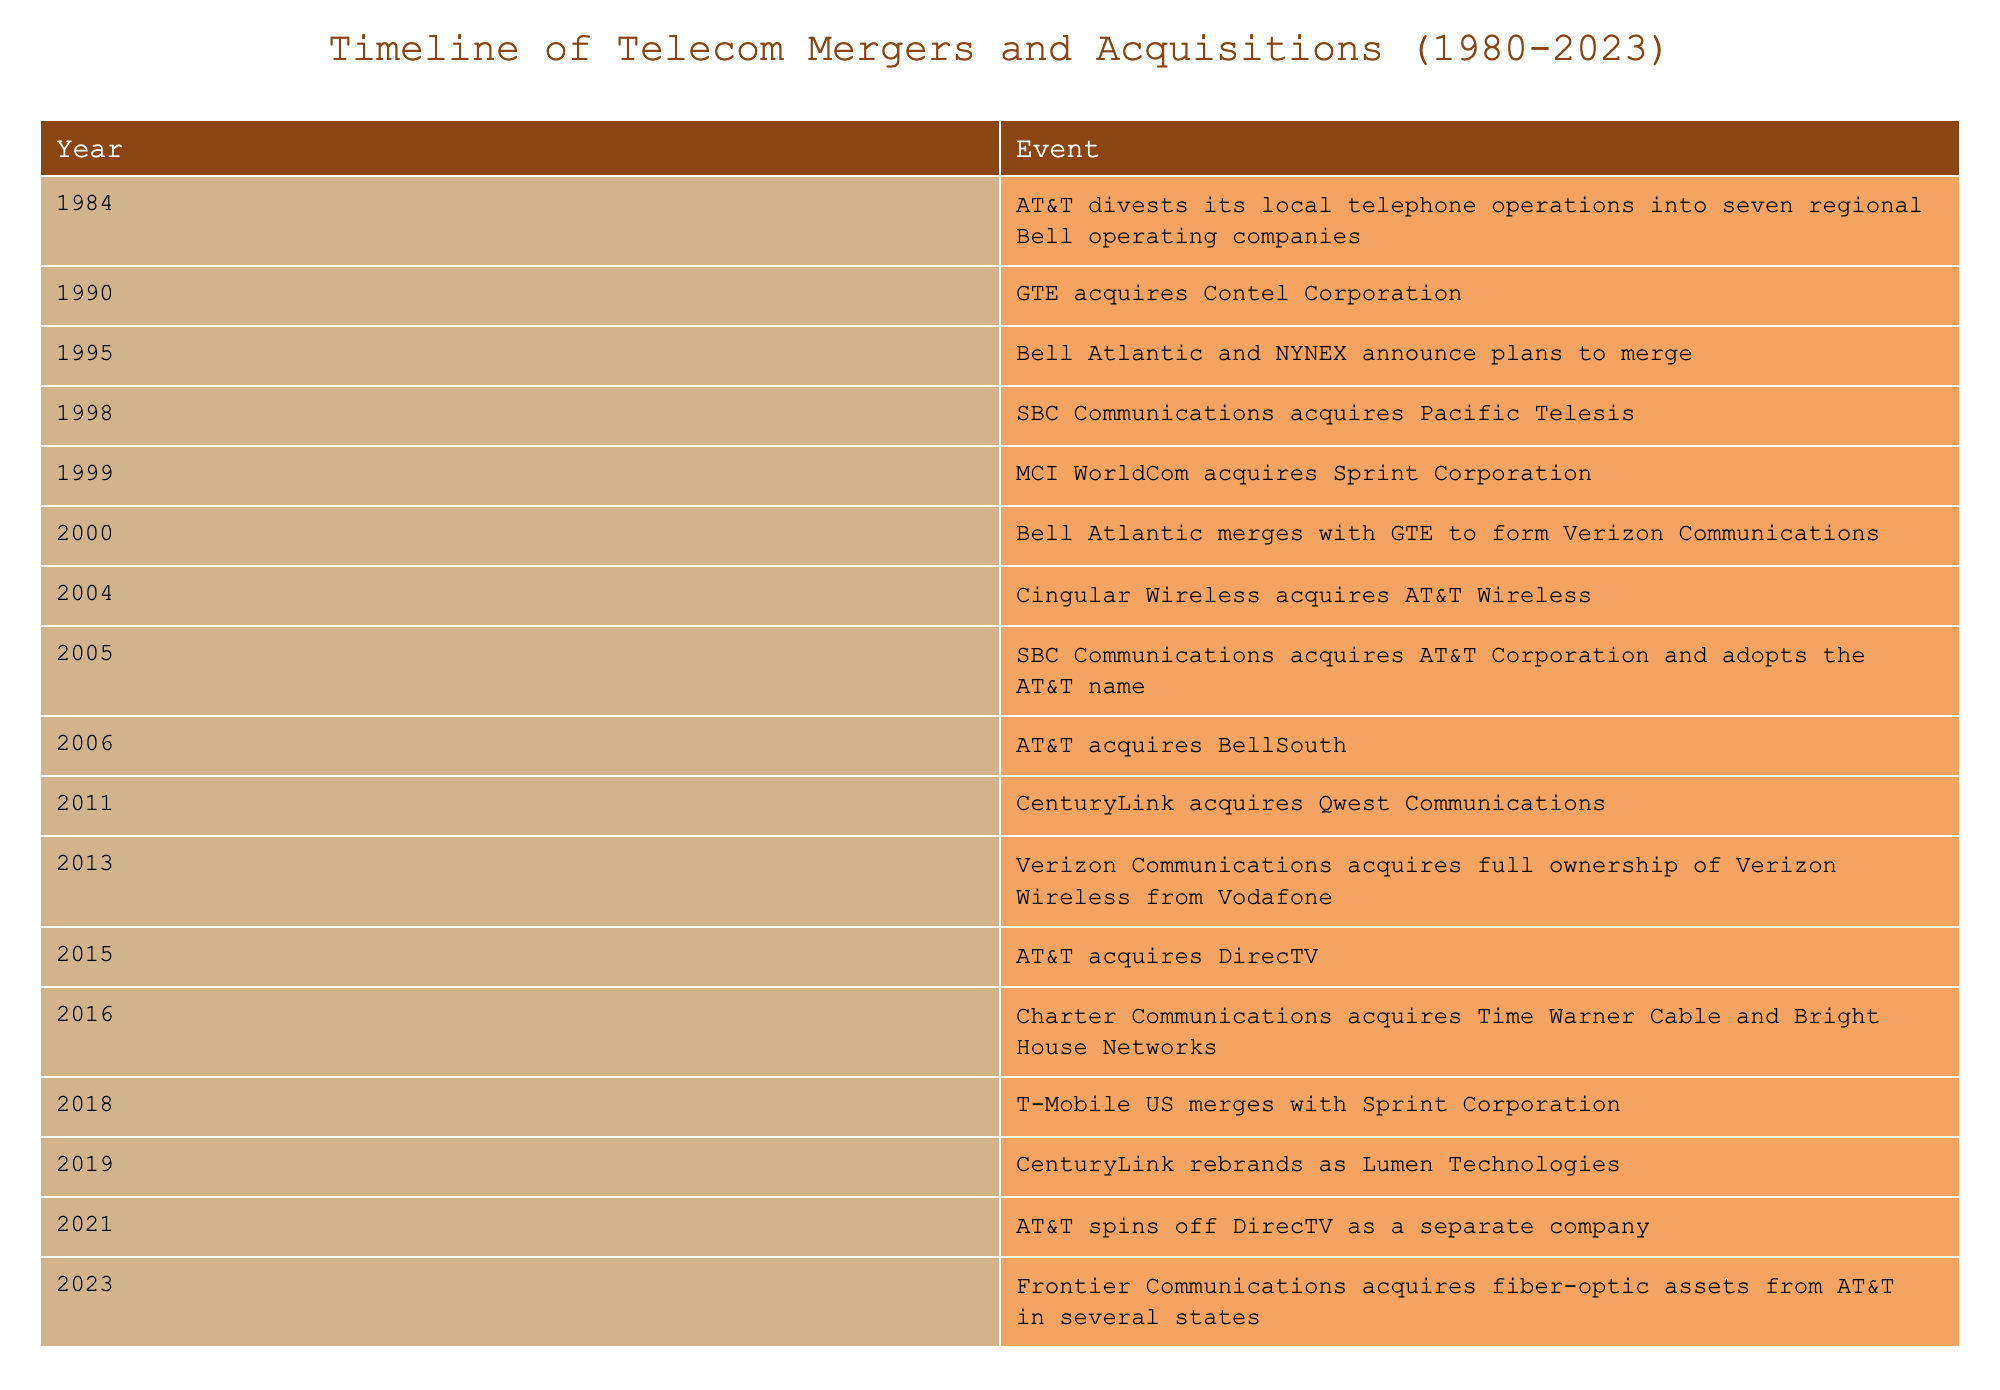What year did AT&T divest its local telephone operations? According to the table, AT&T divested its local telephone operations in 1984.
Answer: 1984 Which company acquired Contel Corporation in 1990? GTE is listed in the table as the company that acquired Contel Corporation in 1990.
Answer: GTE How many mergers or acquisitions occurred in the 2000s? The years in the 2000s listed in the table are 2000 (Bell Atlantic merges with GTE), 2004 (Cingular Wireless acquires AT&T Wireless), 2005 (SBC Communications acquires AT&T Corporation), and 2006 (AT&T acquires BellSouth), summing to four occurrences.
Answer: 4 Did CenturyLink acquire Qwest Communications before or after 2011? The table states that CenturyLink acquired Qwest Communications in 2011, which means the acquisition occurred in that year.
Answer: Before What is the chronological order of the significant mergers and acquisitions from 1995 to 2006? From the table, the events from 1995 to 2006 are as follows: 1995 (Bell Atlantic and NYNEX), 1998 (SBC Communications acquires Pacific Telesis), 1999 (MCI WorldCom acquires Sprint Corporation), 2000 (Bell Atlantic merges with GTE), 2004 (Cingular Wireless acquires AT&T Wireless), and 2005 (SBC Communications acquires AT&T Corporation), making the order: Bell Atlantic and NYNEX, SBC acquires Pacific Telesis, MCI WorldCom acquires Sprint, Bell Atlantic merges with GTE, Cingular Wireless acquires AT&T Wireless, SBC acquires AT&T.
Answer: Bell Atlantic and NYNEX, SBC acquires Pacific Telesis, MCI WorldCom acquires Sprint, Bell Atlantic merges with GTE, Cingular Wireless acquires AT&T Wireless, SBC acquires AT&T How many companies acquired DirecTV, and what were their names? The table indicates that AT&T acquired DirecTV in 2015, and AT&T itself spun off DirecTV as a separate company in 2021. This means AT&T is the only company associated with the acquisition of DirecTV, first acquiring it and later separating from it.
Answer: 1 (AT&T) 